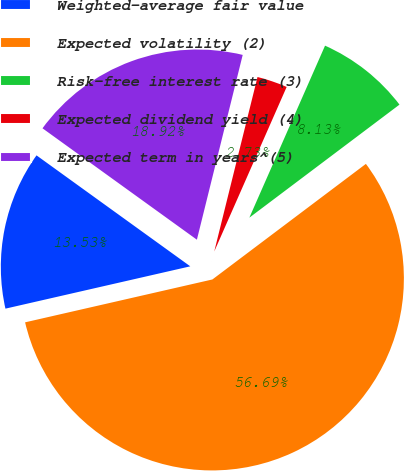Convert chart. <chart><loc_0><loc_0><loc_500><loc_500><pie_chart><fcel>Weighted-average fair value<fcel>Expected volatility (2)<fcel>Risk-free interest rate (3)<fcel>Expected dividend yield (4)<fcel>Expected term in years^(5)<nl><fcel>13.53%<fcel>56.69%<fcel>8.13%<fcel>2.73%<fcel>18.92%<nl></chart> 